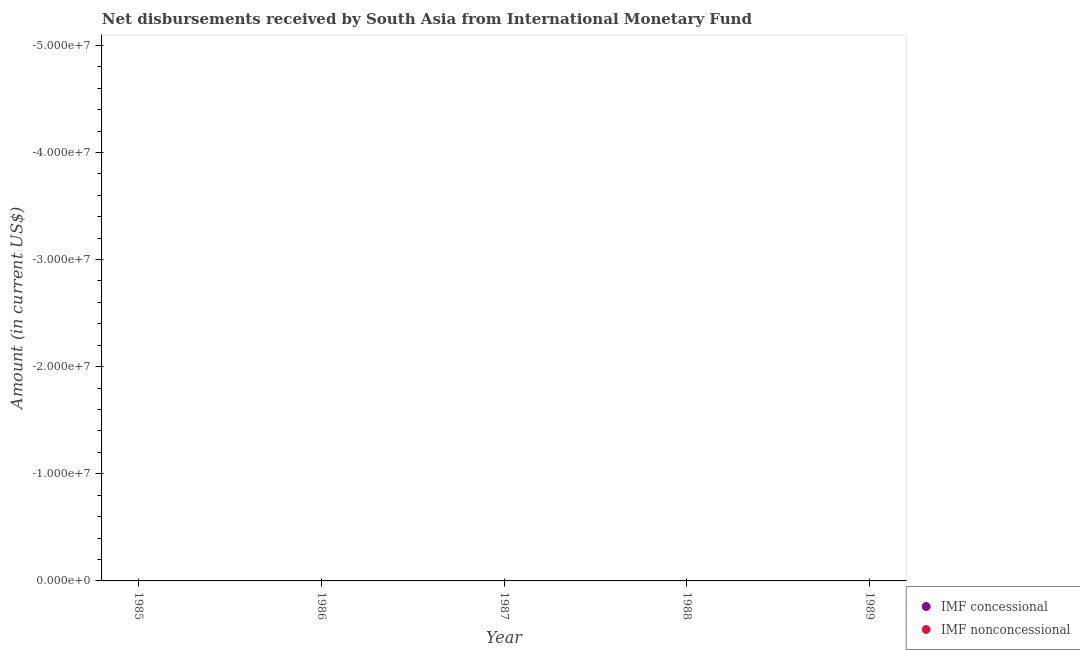How many different coloured dotlines are there?
Offer a very short reply. 0. Is the number of dotlines equal to the number of legend labels?
Your answer should be very brief. No. What is the total net concessional disbursements from imf in the graph?
Make the answer very short. 0. What is the difference between the net non concessional disbursements from imf in 1987 and the net concessional disbursements from imf in 1986?
Provide a short and direct response. 0. How many years are there in the graph?
Offer a terse response. 5. Are the values on the major ticks of Y-axis written in scientific E-notation?
Your response must be concise. Yes. Does the graph contain any zero values?
Make the answer very short. Yes. How many legend labels are there?
Provide a succinct answer. 2. How are the legend labels stacked?
Your answer should be compact. Vertical. What is the title of the graph?
Your answer should be compact. Net disbursements received by South Asia from International Monetary Fund. What is the label or title of the Y-axis?
Offer a terse response. Amount (in current US$). What is the Amount (in current US$) in IMF concessional in 1986?
Provide a succinct answer. 0. What is the Amount (in current US$) of IMF nonconcessional in 1986?
Provide a succinct answer. 0. What is the Amount (in current US$) of IMF concessional in 1989?
Your answer should be very brief. 0. What is the Amount (in current US$) of IMF nonconcessional in 1989?
Offer a terse response. 0. What is the total Amount (in current US$) in IMF nonconcessional in the graph?
Your answer should be very brief. 0. 